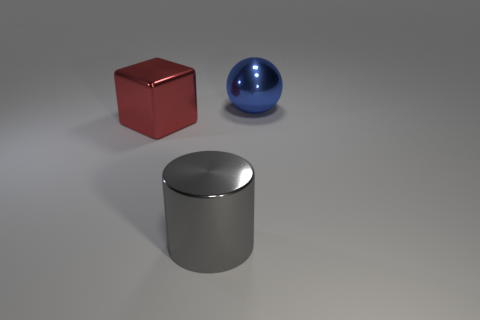Add 2 metal balls. How many objects exist? 5 Add 2 big red metallic blocks. How many big red metallic blocks exist? 3 Subtract 1 red cubes. How many objects are left? 2 Subtract all big blue metallic blocks. Subtract all large shiny objects. How many objects are left? 0 Add 2 big red metal blocks. How many big red metal blocks are left? 3 